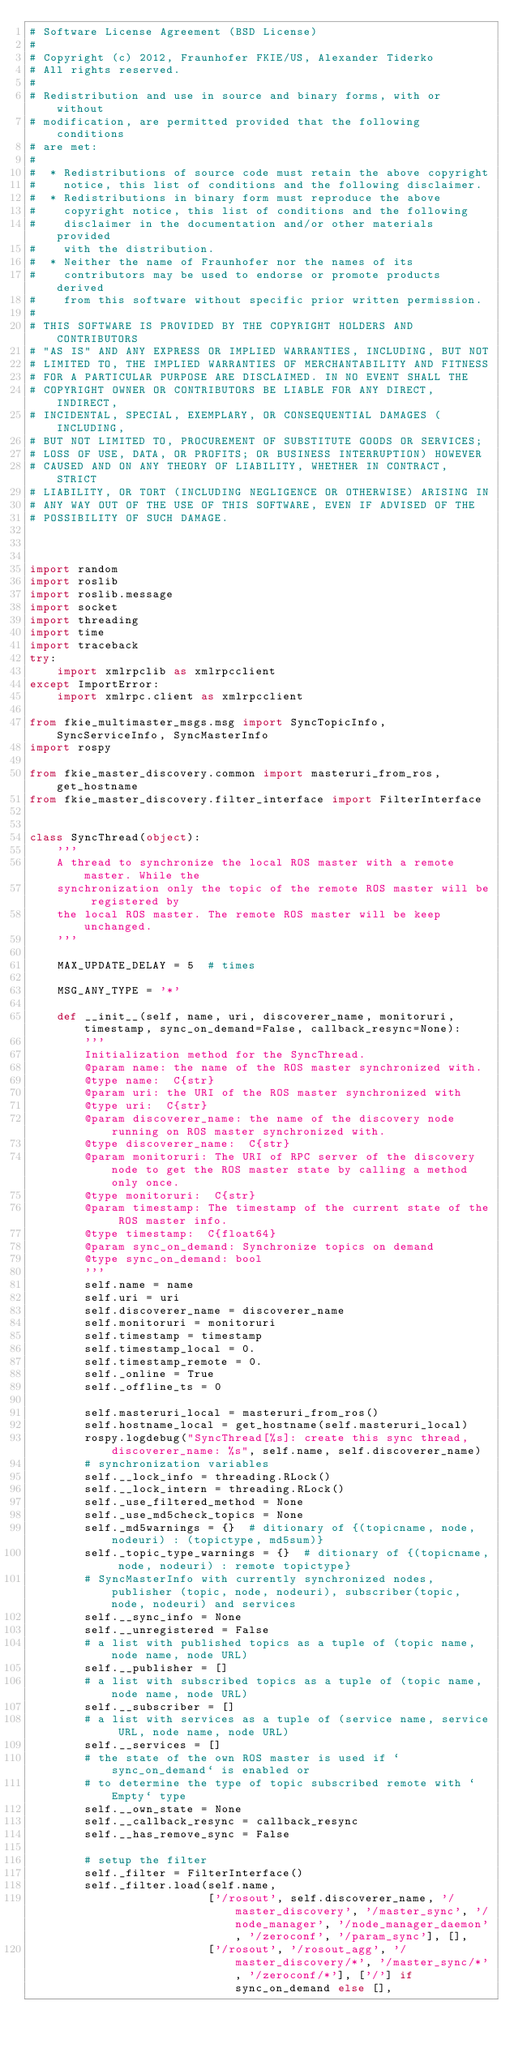Convert code to text. <code><loc_0><loc_0><loc_500><loc_500><_Python_># Software License Agreement (BSD License)
#
# Copyright (c) 2012, Fraunhofer FKIE/US, Alexander Tiderko
# All rights reserved.
#
# Redistribution and use in source and binary forms, with or without
# modification, are permitted provided that the following conditions
# are met:
#
#  * Redistributions of source code must retain the above copyright
#    notice, this list of conditions and the following disclaimer.
#  * Redistributions in binary form must reproduce the above
#    copyright notice, this list of conditions and the following
#    disclaimer in the documentation and/or other materials provided
#    with the distribution.
#  * Neither the name of Fraunhofer nor the names of its
#    contributors may be used to endorse or promote products derived
#    from this software without specific prior written permission.
#
# THIS SOFTWARE IS PROVIDED BY THE COPYRIGHT HOLDERS AND CONTRIBUTORS
# "AS IS" AND ANY EXPRESS OR IMPLIED WARRANTIES, INCLUDING, BUT NOT
# LIMITED TO, THE IMPLIED WARRANTIES OF MERCHANTABILITY AND FITNESS
# FOR A PARTICULAR PURPOSE ARE DISCLAIMED. IN NO EVENT SHALL THE
# COPYRIGHT OWNER OR CONTRIBUTORS BE LIABLE FOR ANY DIRECT, INDIRECT,
# INCIDENTAL, SPECIAL, EXEMPLARY, OR CONSEQUENTIAL DAMAGES (INCLUDING,
# BUT NOT LIMITED TO, PROCUREMENT OF SUBSTITUTE GOODS OR SERVICES;
# LOSS OF USE, DATA, OR PROFITS; OR BUSINESS INTERRUPTION) HOWEVER
# CAUSED AND ON ANY THEORY OF LIABILITY, WHETHER IN CONTRACT, STRICT
# LIABILITY, OR TORT (INCLUDING NEGLIGENCE OR OTHERWISE) ARISING IN
# ANY WAY OUT OF THE USE OF THIS SOFTWARE, EVEN IF ADVISED OF THE
# POSSIBILITY OF SUCH DAMAGE.



import random
import roslib
import roslib.message
import socket
import threading
import time
import traceback
try:
    import xmlrpclib as xmlrpcclient
except ImportError:
    import xmlrpc.client as xmlrpcclient

from fkie_multimaster_msgs.msg import SyncTopicInfo, SyncServiceInfo, SyncMasterInfo
import rospy

from fkie_master_discovery.common import masteruri_from_ros, get_hostname
from fkie_master_discovery.filter_interface import FilterInterface


class SyncThread(object):
    '''
    A thread to synchronize the local ROS master with a remote master. While the
    synchronization only the topic of the remote ROS master will be registered by
    the local ROS master. The remote ROS master will be keep unchanged.
    '''

    MAX_UPDATE_DELAY = 5  # times

    MSG_ANY_TYPE = '*'

    def __init__(self, name, uri, discoverer_name, monitoruri, timestamp, sync_on_demand=False, callback_resync=None):
        '''
        Initialization method for the SyncThread.
        @param name: the name of the ROS master synchronized with.
        @type name:  C{str}
        @param uri: the URI of the ROS master synchronized with
        @type uri:  C{str}
        @param discoverer_name: the name of the discovery node running on ROS master synchronized with.
        @type discoverer_name:  C{str}
        @param monitoruri: The URI of RPC server of the discovery node to get the ROS master state by calling a method only once.
        @type monitoruri:  C{str}
        @param timestamp: The timestamp of the current state of the ROS master info.
        @type timestamp:  C{float64}
        @param sync_on_demand: Synchronize topics on demand
        @type sync_on_demand: bool
        '''
        self.name = name
        self.uri = uri
        self.discoverer_name = discoverer_name
        self.monitoruri = monitoruri
        self.timestamp = timestamp
        self.timestamp_local = 0.
        self.timestamp_remote = 0.
        self._online = True
        self._offline_ts = 0

        self.masteruri_local = masteruri_from_ros()
        self.hostname_local = get_hostname(self.masteruri_local)
        rospy.logdebug("SyncThread[%s]: create this sync thread, discoverer_name: %s", self.name, self.discoverer_name)
        # synchronization variables
        self.__lock_info = threading.RLock()
        self.__lock_intern = threading.RLock()
        self._use_filtered_method = None
        self._use_md5check_topics = None
        self._md5warnings = {}  # ditionary of {(topicname, node, nodeuri) : (topictype, md5sum)}
        self._topic_type_warnings = {}  # ditionary of {(topicname, node, nodeuri) : remote topictype}
        # SyncMasterInfo with currently synchronized nodes, publisher (topic, node, nodeuri), subscriber(topic, node, nodeuri) and services
        self.__sync_info = None
        self.__unregistered = False
        # a list with published topics as a tuple of (topic name, node name, node URL)
        self.__publisher = []
        # a list with subscribed topics as a tuple of (topic name, node name, node URL)
        self.__subscriber = []
        # a list with services as a tuple of (service name, service URL, node name, node URL)
        self.__services = []
        # the state of the own ROS master is used if `sync_on_demand` is enabled or
        # to determine the type of topic subscribed remote with `Empty` type
        self.__own_state = None
        self.__callback_resync = callback_resync
        self.__has_remove_sync = False

        # setup the filter
        self._filter = FilterInterface()
        self._filter.load(self.name,
                          ['/rosout', self.discoverer_name, '/master_discovery', '/master_sync', '/node_manager', '/node_manager_daemon', '/zeroconf', '/param_sync'], [],
                          ['/rosout', '/rosout_agg', '/master_discovery/*', '/master_sync/*', '/zeroconf/*'], ['/'] if sync_on_demand else [],</code> 